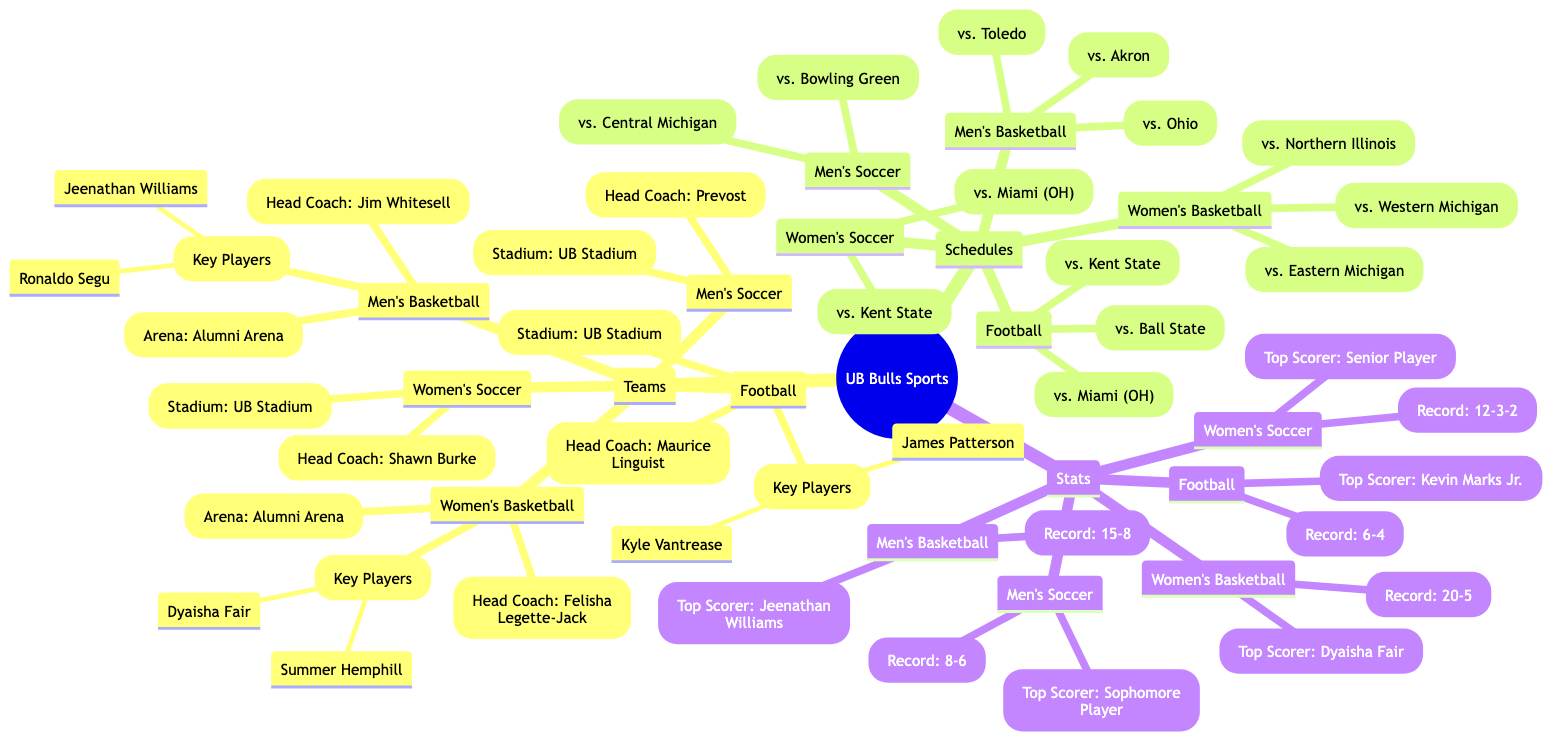What's the head coach of the Men's Basketball team? The Men's Basketball team head coach is listed under the Teams section in the diagram. By locating the Men's Basketball node, we can identify that Jim Whitesell is the head coach.
Answer: Jim Whitesell Which stadium hosts the Football team? The diagram presents the stadiums for each team in the Teams section. By examining the Football node, we can see that the Football team plays at UB Stadium.
Answer: UB Stadium How many upcoming games does the Women's Basketball team have? We can find the Women's Basketball upcoming games listed under the Schedules section. Counting the listed games shows there are three upcoming games.
Answer: 3 What is the current record of the Men's Soccer team? The current records of each team are found in the Stats section. By checking the Men's Soccer node, we find that their current record is 8-6.
Answer: 8-6 Who is the top scorer for the Women's Basketball team? The top scorer for each team is detailed in the Stats section. In the Women's Basketball node, the top scorer is listed as Dyaisha Fair.
Answer: Dyaisha Fair What is unique about the Women's Soccer team's upcoming games? Looking through the Schedules section, we find the Women's Soccer team's upcoming games. Notably, both of their games are against teams from the MAC conference, which showcases their competition level.
Answer: MAC conference Which team has the highest current record? By comparing the current records in the Stats section for all teams, we find that the Women's Basketball team holds the highest record at 20-5.
Answer: 20-5 What is the relationship between the Head Coach of Men's Soccer and the Stadium? The Men's Soccer team's Head Coach, Prevost, is connected to the UB Stadium node, which indicates the venue for the games, establishing a direct association between the coach and the team's home games location.
Answer: UB Stadium How many teams are there in total represented in the diagram? The diagram lists five teams within the Teams section. Counting Football, Men's Basketball, Women's Basketball, Men's Soccer, and Women's Soccer gives us a total of five teams represented.
Answer: 5 